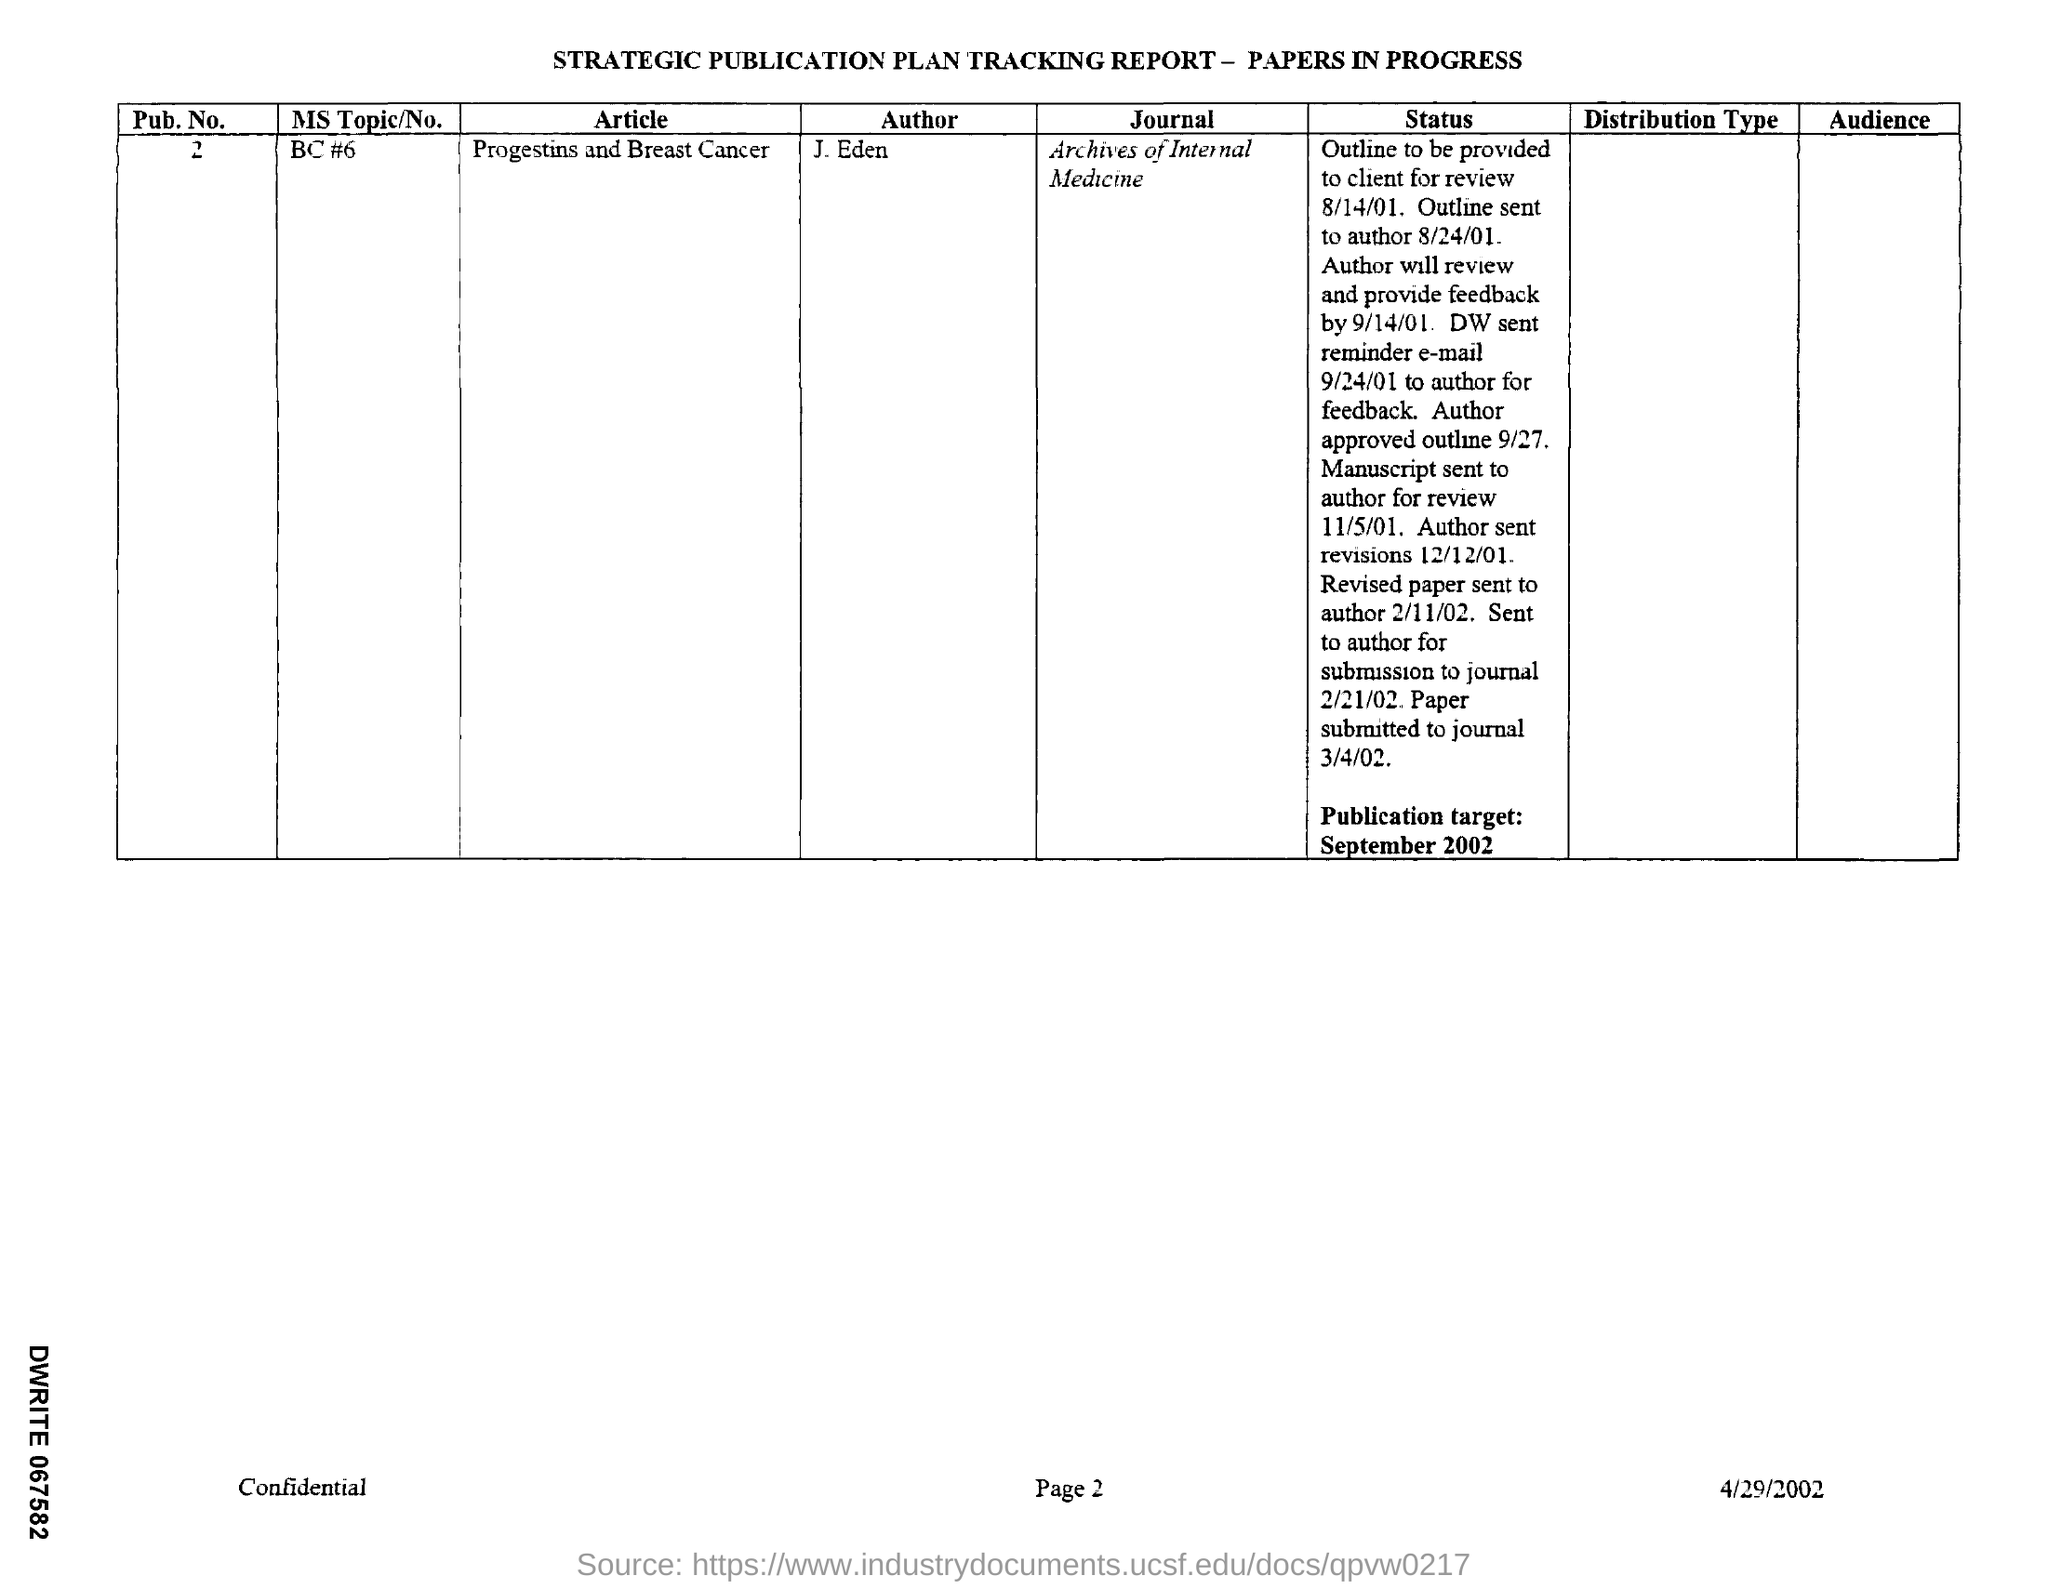In which Journal is the paper going to be published? The paper titled 'Progestins and Breast Cancer' by J. Eden is slated for publication in the 'Archives of Internal Medicine.' This journal, known for its focus on internal medicine, is an appropriate venue for this research, highlighting important findings in the field. 